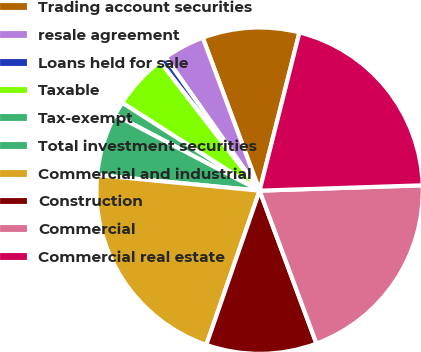Convert chart to OTSL. <chart><loc_0><loc_0><loc_500><loc_500><pie_chart><fcel>Trading account securities<fcel>resale agreement<fcel>Loans held for sale<fcel>Taxable<fcel>Tax-exempt<fcel>Total investment securities<fcel>Commercial and industrial<fcel>Construction<fcel>Commercial<fcel>Commercial real estate<nl><fcel>9.59%<fcel>4.11%<fcel>0.69%<fcel>5.48%<fcel>1.37%<fcel>6.17%<fcel>21.23%<fcel>10.96%<fcel>19.86%<fcel>20.55%<nl></chart> 